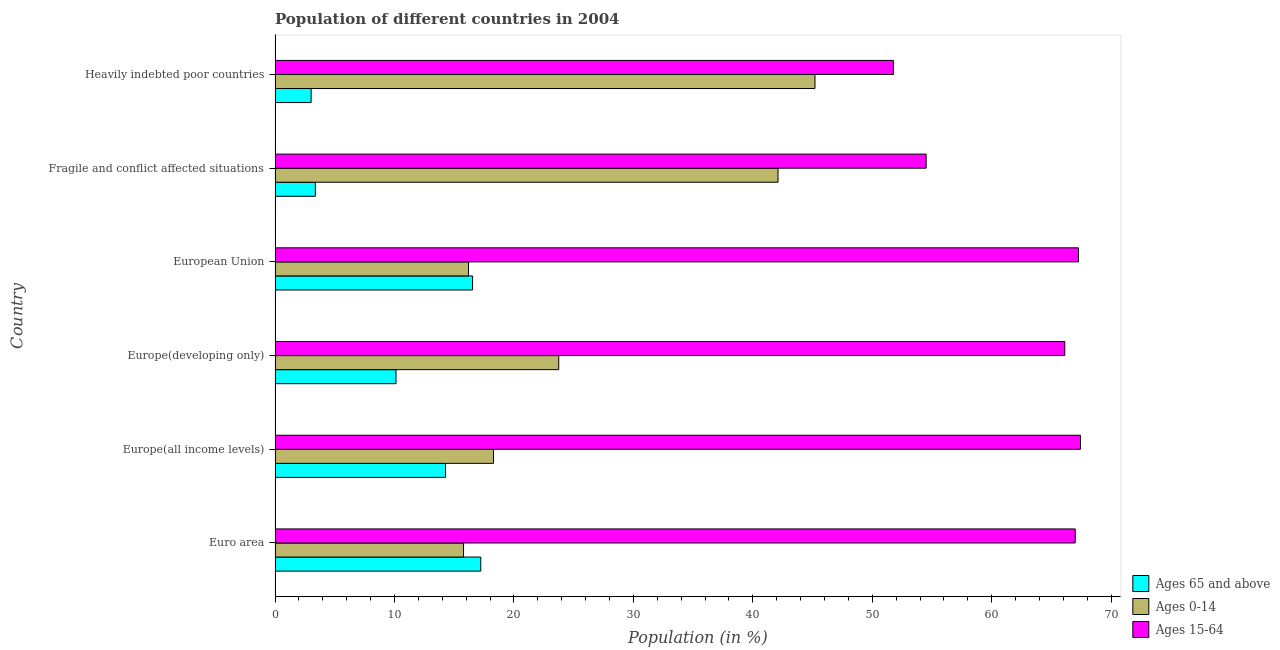How many different coloured bars are there?
Provide a succinct answer. 3. How many groups of bars are there?
Give a very brief answer. 6. Are the number of bars per tick equal to the number of legend labels?
Offer a terse response. Yes. Are the number of bars on each tick of the Y-axis equal?
Offer a very short reply. Yes. How many bars are there on the 2nd tick from the bottom?
Ensure brevity in your answer.  3. What is the label of the 4th group of bars from the top?
Offer a terse response. Europe(developing only). In how many cases, is the number of bars for a given country not equal to the number of legend labels?
Provide a short and direct response. 0. What is the percentage of population within the age-group of 65 and above in Fragile and conflict affected situations?
Your answer should be compact. 3.37. Across all countries, what is the maximum percentage of population within the age-group 0-14?
Your answer should be compact. 45.21. Across all countries, what is the minimum percentage of population within the age-group 15-64?
Offer a very short reply. 51.77. In which country was the percentage of population within the age-group 15-64 minimum?
Your answer should be compact. Heavily indebted poor countries. What is the total percentage of population within the age-group 15-64 in the graph?
Ensure brevity in your answer.  374.12. What is the difference between the percentage of population within the age-group 15-64 in Euro area and that in Europe(all income levels)?
Your answer should be compact. -0.44. What is the difference between the percentage of population within the age-group 0-14 in Heavily indebted poor countries and the percentage of population within the age-group 15-64 in Fragile and conflict affected situations?
Your answer should be compact. -9.31. What is the average percentage of population within the age-group 0-14 per country?
Offer a terse response. 26.89. What is the difference between the percentage of population within the age-group 0-14 and percentage of population within the age-group 15-64 in Euro area?
Your response must be concise. -51.22. In how many countries, is the percentage of population within the age-group 15-64 greater than 18 %?
Provide a short and direct response. 6. What is the ratio of the percentage of population within the age-group 0-14 in Euro area to that in Heavily indebted poor countries?
Ensure brevity in your answer.  0.35. Is the percentage of population within the age-group 15-64 in Europe(developing only) less than that in Fragile and conflict affected situations?
Your answer should be compact. No. Is the difference between the percentage of population within the age-group of 65 and above in Europe(developing only) and Fragile and conflict affected situations greater than the difference between the percentage of population within the age-group 0-14 in Europe(developing only) and Fragile and conflict affected situations?
Provide a short and direct response. Yes. What is the difference between the highest and the second highest percentage of population within the age-group 15-64?
Keep it short and to the point. 0.17. Is the sum of the percentage of population within the age-group 0-14 in European Union and Fragile and conflict affected situations greater than the maximum percentage of population within the age-group 15-64 across all countries?
Provide a succinct answer. No. What does the 2nd bar from the top in European Union represents?
Provide a succinct answer. Ages 0-14. What does the 3rd bar from the bottom in Heavily indebted poor countries represents?
Ensure brevity in your answer.  Ages 15-64. Is it the case that in every country, the sum of the percentage of population within the age-group of 65 and above and percentage of population within the age-group 0-14 is greater than the percentage of population within the age-group 15-64?
Provide a short and direct response. No. How many bars are there?
Keep it short and to the point. 18. What is the difference between two consecutive major ticks on the X-axis?
Offer a very short reply. 10. Are the values on the major ticks of X-axis written in scientific E-notation?
Offer a very short reply. No. Does the graph contain grids?
Ensure brevity in your answer.  No. Where does the legend appear in the graph?
Offer a very short reply. Bottom right. What is the title of the graph?
Keep it short and to the point. Population of different countries in 2004. What is the label or title of the X-axis?
Offer a very short reply. Population (in %). What is the Population (in %) in Ages 65 and above in Euro area?
Keep it short and to the point. 17.22. What is the Population (in %) in Ages 0-14 in Euro area?
Provide a short and direct response. 15.78. What is the Population (in %) of Ages 15-64 in Euro area?
Offer a very short reply. 67. What is the Population (in %) of Ages 65 and above in Europe(all income levels)?
Your response must be concise. 14.27. What is the Population (in %) of Ages 0-14 in Europe(all income levels)?
Your answer should be compact. 18.29. What is the Population (in %) of Ages 15-64 in Europe(all income levels)?
Your answer should be compact. 67.44. What is the Population (in %) in Ages 65 and above in Europe(developing only)?
Give a very brief answer. 10.13. What is the Population (in %) of Ages 0-14 in Europe(developing only)?
Ensure brevity in your answer.  23.75. What is the Population (in %) of Ages 15-64 in Europe(developing only)?
Your response must be concise. 66.12. What is the Population (in %) of Ages 65 and above in European Union?
Offer a terse response. 16.53. What is the Population (in %) of Ages 0-14 in European Union?
Offer a terse response. 16.2. What is the Population (in %) in Ages 15-64 in European Union?
Provide a short and direct response. 67.27. What is the Population (in %) in Ages 65 and above in Fragile and conflict affected situations?
Ensure brevity in your answer.  3.37. What is the Population (in %) in Ages 0-14 in Fragile and conflict affected situations?
Your answer should be very brief. 42.11. What is the Population (in %) of Ages 15-64 in Fragile and conflict affected situations?
Make the answer very short. 54.51. What is the Population (in %) in Ages 65 and above in Heavily indebted poor countries?
Provide a short and direct response. 3.02. What is the Population (in %) in Ages 0-14 in Heavily indebted poor countries?
Your answer should be compact. 45.21. What is the Population (in %) of Ages 15-64 in Heavily indebted poor countries?
Offer a terse response. 51.77. Across all countries, what is the maximum Population (in %) of Ages 65 and above?
Keep it short and to the point. 17.22. Across all countries, what is the maximum Population (in %) in Ages 0-14?
Offer a very short reply. 45.21. Across all countries, what is the maximum Population (in %) in Ages 15-64?
Make the answer very short. 67.44. Across all countries, what is the minimum Population (in %) in Ages 65 and above?
Your answer should be compact. 3.02. Across all countries, what is the minimum Population (in %) in Ages 0-14?
Offer a very short reply. 15.78. Across all countries, what is the minimum Population (in %) in Ages 15-64?
Offer a very short reply. 51.77. What is the total Population (in %) in Ages 65 and above in the graph?
Your answer should be very brief. 64.54. What is the total Population (in %) of Ages 0-14 in the graph?
Your answer should be compact. 161.34. What is the total Population (in %) in Ages 15-64 in the graph?
Provide a succinct answer. 374.12. What is the difference between the Population (in %) of Ages 65 and above in Euro area and that in Europe(all income levels)?
Your answer should be very brief. 2.95. What is the difference between the Population (in %) of Ages 0-14 in Euro area and that in Europe(all income levels)?
Offer a very short reply. -2.51. What is the difference between the Population (in %) of Ages 15-64 in Euro area and that in Europe(all income levels)?
Keep it short and to the point. -0.44. What is the difference between the Population (in %) in Ages 65 and above in Euro area and that in Europe(developing only)?
Ensure brevity in your answer.  7.1. What is the difference between the Population (in %) of Ages 0-14 in Euro area and that in Europe(developing only)?
Offer a very short reply. -7.97. What is the difference between the Population (in %) in Ages 15-64 in Euro area and that in Europe(developing only)?
Offer a very short reply. 0.88. What is the difference between the Population (in %) in Ages 65 and above in Euro area and that in European Union?
Make the answer very short. 0.69. What is the difference between the Population (in %) of Ages 0-14 in Euro area and that in European Union?
Give a very brief answer. -0.42. What is the difference between the Population (in %) in Ages 15-64 in Euro area and that in European Union?
Offer a very short reply. -0.27. What is the difference between the Population (in %) in Ages 65 and above in Euro area and that in Fragile and conflict affected situations?
Make the answer very short. 13.85. What is the difference between the Population (in %) in Ages 0-14 in Euro area and that in Fragile and conflict affected situations?
Keep it short and to the point. -26.33. What is the difference between the Population (in %) in Ages 15-64 in Euro area and that in Fragile and conflict affected situations?
Make the answer very short. 12.48. What is the difference between the Population (in %) of Ages 65 and above in Euro area and that in Heavily indebted poor countries?
Your answer should be very brief. 14.2. What is the difference between the Population (in %) of Ages 0-14 in Euro area and that in Heavily indebted poor countries?
Ensure brevity in your answer.  -29.43. What is the difference between the Population (in %) of Ages 15-64 in Euro area and that in Heavily indebted poor countries?
Offer a terse response. 15.22. What is the difference between the Population (in %) of Ages 65 and above in Europe(all income levels) and that in Europe(developing only)?
Give a very brief answer. 4.14. What is the difference between the Population (in %) of Ages 0-14 in Europe(all income levels) and that in Europe(developing only)?
Ensure brevity in your answer.  -5.46. What is the difference between the Population (in %) of Ages 15-64 in Europe(all income levels) and that in Europe(developing only)?
Your answer should be very brief. 1.32. What is the difference between the Population (in %) in Ages 65 and above in Europe(all income levels) and that in European Union?
Ensure brevity in your answer.  -2.26. What is the difference between the Population (in %) of Ages 0-14 in Europe(all income levels) and that in European Union?
Offer a terse response. 2.09. What is the difference between the Population (in %) in Ages 15-64 in Europe(all income levels) and that in European Union?
Give a very brief answer. 0.17. What is the difference between the Population (in %) of Ages 65 and above in Europe(all income levels) and that in Fragile and conflict affected situations?
Ensure brevity in your answer.  10.9. What is the difference between the Population (in %) of Ages 0-14 in Europe(all income levels) and that in Fragile and conflict affected situations?
Your answer should be compact. -23.82. What is the difference between the Population (in %) in Ages 15-64 in Europe(all income levels) and that in Fragile and conflict affected situations?
Ensure brevity in your answer.  12.93. What is the difference between the Population (in %) of Ages 65 and above in Europe(all income levels) and that in Heavily indebted poor countries?
Keep it short and to the point. 11.25. What is the difference between the Population (in %) in Ages 0-14 in Europe(all income levels) and that in Heavily indebted poor countries?
Offer a very short reply. -26.92. What is the difference between the Population (in %) in Ages 15-64 in Europe(all income levels) and that in Heavily indebted poor countries?
Your answer should be very brief. 15.67. What is the difference between the Population (in %) of Ages 65 and above in Europe(developing only) and that in European Union?
Give a very brief answer. -6.41. What is the difference between the Population (in %) of Ages 0-14 in Europe(developing only) and that in European Union?
Offer a very short reply. 7.56. What is the difference between the Population (in %) of Ages 15-64 in Europe(developing only) and that in European Union?
Your answer should be very brief. -1.15. What is the difference between the Population (in %) in Ages 65 and above in Europe(developing only) and that in Fragile and conflict affected situations?
Make the answer very short. 6.75. What is the difference between the Population (in %) in Ages 0-14 in Europe(developing only) and that in Fragile and conflict affected situations?
Offer a terse response. -18.36. What is the difference between the Population (in %) of Ages 15-64 in Europe(developing only) and that in Fragile and conflict affected situations?
Give a very brief answer. 11.61. What is the difference between the Population (in %) of Ages 65 and above in Europe(developing only) and that in Heavily indebted poor countries?
Make the answer very short. 7.11. What is the difference between the Population (in %) in Ages 0-14 in Europe(developing only) and that in Heavily indebted poor countries?
Provide a succinct answer. -21.45. What is the difference between the Population (in %) in Ages 15-64 in Europe(developing only) and that in Heavily indebted poor countries?
Ensure brevity in your answer.  14.35. What is the difference between the Population (in %) in Ages 65 and above in European Union and that in Fragile and conflict affected situations?
Make the answer very short. 13.16. What is the difference between the Population (in %) in Ages 0-14 in European Union and that in Fragile and conflict affected situations?
Your answer should be very brief. -25.92. What is the difference between the Population (in %) in Ages 15-64 in European Union and that in Fragile and conflict affected situations?
Your answer should be compact. 12.76. What is the difference between the Population (in %) of Ages 65 and above in European Union and that in Heavily indebted poor countries?
Give a very brief answer. 13.51. What is the difference between the Population (in %) of Ages 0-14 in European Union and that in Heavily indebted poor countries?
Your answer should be compact. -29.01. What is the difference between the Population (in %) of Ages 15-64 in European Union and that in Heavily indebted poor countries?
Ensure brevity in your answer.  15.5. What is the difference between the Population (in %) in Ages 65 and above in Fragile and conflict affected situations and that in Heavily indebted poor countries?
Offer a terse response. 0.35. What is the difference between the Population (in %) in Ages 0-14 in Fragile and conflict affected situations and that in Heavily indebted poor countries?
Your answer should be compact. -3.09. What is the difference between the Population (in %) in Ages 15-64 in Fragile and conflict affected situations and that in Heavily indebted poor countries?
Offer a very short reply. 2.74. What is the difference between the Population (in %) in Ages 65 and above in Euro area and the Population (in %) in Ages 0-14 in Europe(all income levels)?
Provide a short and direct response. -1.07. What is the difference between the Population (in %) of Ages 65 and above in Euro area and the Population (in %) of Ages 15-64 in Europe(all income levels)?
Your answer should be very brief. -50.22. What is the difference between the Population (in %) of Ages 0-14 in Euro area and the Population (in %) of Ages 15-64 in Europe(all income levels)?
Provide a short and direct response. -51.66. What is the difference between the Population (in %) of Ages 65 and above in Euro area and the Population (in %) of Ages 0-14 in Europe(developing only)?
Offer a terse response. -6.53. What is the difference between the Population (in %) of Ages 65 and above in Euro area and the Population (in %) of Ages 15-64 in Europe(developing only)?
Your answer should be very brief. -48.9. What is the difference between the Population (in %) in Ages 0-14 in Euro area and the Population (in %) in Ages 15-64 in Europe(developing only)?
Offer a terse response. -50.34. What is the difference between the Population (in %) in Ages 65 and above in Euro area and the Population (in %) in Ages 0-14 in European Union?
Provide a short and direct response. 1.03. What is the difference between the Population (in %) in Ages 65 and above in Euro area and the Population (in %) in Ages 15-64 in European Union?
Keep it short and to the point. -50.05. What is the difference between the Population (in %) in Ages 0-14 in Euro area and the Population (in %) in Ages 15-64 in European Union?
Provide a short and direct response. -51.49. What is the difference between the Population (in %) in Ages 65 and above in Euro area and the Population (in %) in Ages 0-14 in Fragile and conflict affected situations?
Offer a terse response. -24.89. What is the difference between the Population (in %) of Ages 65 and above in Euro area and the Population (in %) of Ages 15-64 in Fragile and conflict affected situations?
Give a very brief answer. -37.29. What is the difference between the Population (in %) in Ages 0-14 in Euro area and the Population (in %) in Ages 15-64 in Fragile and conflict affected situations?
Offer a very short reply. -38.73. What is the difference between the Population (in %) in Ages 65 and above in Euro area and the Population (in %) in Ages 0-14 in Heavily indebted poor countries?
Keep it short and to the point. -27.98. What is the difference between the Population (in %) in Ages 65 and above in Euro area and the Population (in %) in Ages 15-64 in Heavily indebted poor countries?
Make the answer very short. -34.55. What is the difference between the Population (in %) in Ages 0-14 in Euro area and the Population (in %) in Ages 15-64 in Heavily indebted poor countries?
Keep it short and to the point. -35.99. What is the difference between the Population (in %) of Ages 65 and above in Europe(all income levels) and the Population (in %) of Ages 0-14 in Europe(developing only)?
Provide a short and direct response. -9.48. What is the difference between the Population (in %) of Ages 65 and above in Europe(all income levels) and the Population (in %) of Ages 15-64 in Europe(developing only)?
Make the answer very short. -51.85. What is the difference between the Population (in %) in Ages 0-14 in Europe(all income levels) and the Population (in %) in Ages 15-64 in Europe(developing only)?
Offer a terse response. -47.83. What is the difference between the Population (in %) in Ages 65 and above in Europe(all income levels) and the Population (in %) in Ages 0-14 in European Union?
Provide a short and direct response. -1.93. What is the difference between the Population (in %) in Ages 65 and above in Europe(all income levels) and the Population (in %) in Ages 15-64 in European Union?
Offer a very short reply. -53. What is the difference between the Population (in %) of Ages 0-14 in Europe(all income levels) and the Population (in %) of Ages 15-64 in European Union?
Provide a succinct answer. -48.98. What is the difference between the Population (in %) in Ages 65 and above in Europe(all income levels) and the Population (in %) in Ages 0-14 in Fragile and conflict affected situations?
Offer a terse response. -27.84. What is the difference between the Population (in %) of Ages 65 and above in Europe(all income levels) and the Population (in %) of Ages 15-64 in Fragile and conflict affected situations?
Keep it short and to the point. -40.24. What is the difference between the Population (in %) in Ages 0-14 in Europe(all income levels) and the Population (in %) in Ages 15-64 in Fragile and conflict affected situations?
Your answer should be very brief. -36.23. What is the difference between the Population (in %) in Ages 65 and above in Europe(all income levels) and the Population (in %) in Ages 0-14 in Heavily indebted poor countries?
Your answer should be compact. -30.94. What is the difference between the Population (in %) in Ages 65 and above in Europe(all income levels) and the Population (in %) in Ages 15-64 in Heavily indebted poor countries?
Offer a terse response. -37.5. What is the difference between the Population (in %) in Ages 0-14 in Europe(all income levels) and the Population (in %) in Ages 15-64 in Heavily indebted poor countries?
Offer a terse response. -33.48. What is the difference between the Population (in %) in Ages 65 and above in Europe(developing only) and the Population (in %) in Ages 0-14 in European Union?
Give a very brief answer. -6.07. What is the difference between the Population (in %) in Ages 65 and above in Europe(developing only) and the Population (in %) in Ages 15-64 in European Union?
Provide a short and direct response. -57.14. What is the difference between the Population (in %) in Ages 0-14 in Europe(developing only) and the Population (in %) in Ages 15-64 in European Union?
Keep it short and to the point. -43.52. What is the difference between the Population (in %) of Ages 65 and above in Europe(developing only) and the Population (in %) of Ages 0-14 in Fragile and conflict affected situations?
Offer a terse response. -31.99. What is the difference between the Population (in %) of Ages 65 and above in Europe(developing only) and the Population (in %) of Ages 15-64 in Fragile and conflict affected situations?
Offer a terse response. -44.39. What is the difference between the Population (in %) of Ages 0-14 in Europe(developing only) and the Population (in %) of Ages 15-64 in Fragile and conflict affected situations?
Keep it short and to the point. -30.76. What is the difference between the Population (in %) in Ages 65 and above in Europe(developing only) and the Population (in %) in Ages 0-14 in Heavily indebted poor countries?
Provide a succinct answer. -35.08. What is the difference between the Population (in %) in Ages 65 and above in Europe(developing only) and the Population (in %) in Ages 15-64 in Heavily indebted poor countries?
Keep it short and to the point. -41.65. What is the difference between the Population (in %) of Ages 0-14 in Europe(developing only) and the Population (in %) of Ages 15-64 in Heavily indebted poor countries?
Provide a succinct answer. -28.02. What is the difference between the Population (in %) in Ages 65 and above in European Union and the Population (in %) in Ages 0-14 in Fragile and conflict affected situations?
Make the answer very short. -25.58. What is the difference between the Population (in %) of Ages 65 and above in European Union and the Population (in %) of Ages 15-64 in Fragile and conflict affected situations?
Provide a succinct answer. -37.98. What is the difference between the Population (in %) in Ages 0-14 in European Union and the Population (in %) in Ages 15-64 in Fragile and conflict affected situations?
Make the answer very short. -38.32. What is the difference between the Population (in %) of Ages 65 and above in European Union and the Population (in %) of Ages 0-14 in Heavily indebted poor countries?
Offer a very short reply. -28.67. What is the difference between the Population (in %) in Ages 65 and above in European Union and the Population (in %) in Ages 15-64 in Heavily indebted poor countries?
Provide a short and direct response. -35.24. What is the difference between the Population (in %) of Ages 0-14 in European Union and the Population (in %) of Ages 15-64 in Heavily indebted poor countries?
Provide a succinct answer. -35.58. What is the difference between the Population (in %) in Ages 65 and above in Fragile and conflict affected situations and the Population (in %) in Ages 0-14 in Heavily indebted poor countries?
Offer a terse response. -41.83. What is the difference between the Population (in %) of Ages 65 and above in Fragile and conflict affected situations and the Population (in %) of Ages 15-64 in Heavily indebted poor countries?
Offer a terse response. -48.4. What is the difference between the Population (in %) of Ages 0-14 in Fragile and conflict affected situations and the Population (in %) of Ages 15-64 in Heavily indebted poor countries?
Offer a very short reply. -9.66. What is the average Population (in %) of Ages 65 and above per country?
Offer a terse response. 10.76. What is the average Population (in %) of Ages 0-14 per country?
Provide a short and direct response. 26.89. What is the average Population (in %) of Ages 15-64 per country?
Keep it short and to the point. 62.35. What is the difference between the Population (in %) of Ages 65 and above and Population (in %) of Ages 0-14 in Euro area?
Offer a terse response. 1.44. What is the difference between the Population (in %) in Ages 65 and above and Population (in %) in Ages 15-64 in Euro area?
Ensure brevity in your answer.  -49.78. What is the difference between the Population (in %) in Ages 0-14 and Population (in %) in Ages 15-64 in Euro area?
Give a very brief answer. -51.22. What is the difference between the Population (in %) of Ages 65 and above and Population (in %) of Ages 0-14 in Europe(all income levels)?
Keep it short and to the point. -4.02. What is the difference between the Population (in %) in Ages 65 and above and Population (in %) in Ages 15-64 in Europe(all income levels)?
Give a very brief answer. -53.17. What is the difference between the Population (in %) in Ages 0-14 and Population (in %) in Ages 15-64 in Europe(all income levels)?
Make the answer very short. -49.15. What is the difference between the Population (in %) in Ages 65 and above and Population (in %) in Ages 0-14 in Europe(developing only)?
Your answer should be compact. -13.62. What is the difference between the Population (in %) in Ages 65 and above and Population (in %) in Ages 15-64 in Europe(developing only)?
Offer a terse response. -55.99. What is the difference between the Population (in %) of Ages 0-14 and Population (in %) of Ages 15-64 in Europe(developing only)?
Provide a short and direct response. -42.37. What is the difference between the Population (in %) in Ages 65 and above and Population (in %) in Ages 0-14 in European Union?
Offer a very short reply. 0.34. What is the difference between the Population (in %) of Ages 65 and above and Population (in %) of Ages 15-64 in European Union?
Ensure brevity in your answer.  -50.74. What is the difference between the Population (in %) of Ages 0-14 and Population (in %) of Ages 15-64 in European Union?
Your response must be concise. -51.07. What is the difference between the Population (in %) of Ages 65 and above and Population (in %) of Ages 0-14 in Fragile and conflict affected situations?
Provide a short and direct response. -38.74. What is the difference between the Population (in %) in Ages 65 and above and Population (in %) in Ages 15-64 in Fragile and conflict affected situations?
Offer a terse response. -51.14. What is the difference between the Population (in %) of Ages 0-14 and Population (in %) of Ages 15-64 in Fragile and conflict affected situations?
Provide a short and direct response. -12.4. What is the difference between the Population (in %) of Ages 65 and above and Population (in %) of Ages 0-14 in Heavily indebted poor countries?
Keep it short and to the point. -42.19. What is the difference between the Population (in %) in Ages 65 and above and Population (in %) in Ages 15-64 in Heavily indebted poor countries?
Ensure brevity in your answer.  -48.75. What is the difference between the Population (in %) in Ages 0-14 and Population (in %) in Ages 15-64 in Heavily indebted poor countries?
Your answer should be compact. -6.57. What is the ratio of the Population (in %) in Ages 65 and above in Euro area to that in Europe(all income levels)?
Your response must be concise. 1.21. What is the ratio of the Population (in %) in Ages 0-14 in Euro area to that in Europe(all income levels)?
Ensure brevity in your answer.  0.86. What is the ratio of the Population (in %) in Ages 15-64 in Euro area to that in Europe(all income levels)?
Offer a very short reply. 0.99. What is the ratio of the Population (in %) in Ages 65 and above in Euro area to that in Europe(developing only)?
Provide a succinct answer. 1.7. What is the ratio of the Population (in %) of Ages 0-14 in Euro area to that in Europe(developing only)?
Your response must be concise. 0.66. What is the ratio of the Population (in %) of Ages 15-64 in Euro area to that in Europe(developing only)?
Provide a short and direct response. 1.01. What is the ratio of the Population (in %) of Ages 65 and above in Euro area to that in European Union?
Offer a terse response. 1.04. What is the ratio of the Population (in %) in Ages 0-14 in Euro area to that in European Union?
Give a very brief answer. 0.97. What is the ratio of the Population (in %) in Ages 15-64 in Euro area to that in European Union?
Provide a short and direct response. 1. What is the ratio of the Population (in %) of Ages 65 and above in Euro area to that in Fragile and conflict affected situations?
Keep it short and to the point. 5.11. What is the ratio of the Population (in %) of Ages 0-14 in Euro area to that in Fragile and conflict affected situations?
Offer a very short reply. 0.37. What is the ratio of the Population (in %) of Ages 15-64 in Euro area to that in Fragile and conflict affected situations?
Provide a short and direct response. 1.23. What is the ratio of the Population (in %) in Ages 65 and above in Euro area to that in Heavily indebted poor countries?
Your answer should be compact. 5.7. What is the ratio of the Population (in %) of Ages 0-14 in Euro area to that in Heavily indebted poor countries?
Offer a very short reply. 0.35. What is the ratio of the Population (in %) of Ages 15-64 in Euro area to that in Heavily indebted poor countries?
Keep it short and to the point. 1.29. What is the ratio of the Population (in %) in Ages 65 and above in Europe(all income levels) to that in Europe(developing only)?
Provide a short and direct response. 1.41. What is the ratio of the Population (in %) in Ages 0-14 in Europe(all income levels) to that in Europe(developing only)?
Offer a terse response. 0.77. What is the ratio of the Population (in %) in Ages 65 and above in Europe(all income levels) to that in European Union?
Keep it short and to the point. 0.86. What is the ratio of the Population (in %) in Ages 0-14 in Europe(all income levels) to that in European Union?
Offer a terse response. 1.13. What is the ratio of the Population (in %) of Ages 15-64 in Europe(all income levels) to that in European Union?
Your answer should be very brief. 1. What is the ratio of the Population (in %) in Ages 65 and above in Europe(all income levels) to that in Fragile and conflict affected situations?
Offer a terse response. 4.23. What is the ratio of the Population (in %) of Ages 0-14 in Europe(all income levels) to that in Fragile and conflict affected situations?
Make the answer very short. 0.43. What is the ratio of the Population (in %) in Ages 15-64 in Europe(all income levels) to that in Fragile and conflict affected situations?
Give a very brief answer. 1.24. What is the ratio of the Population (in %) in Ages 65 and above in Europe(all income levels) to that in Heavily indebted poor countries?
Provide a succinct answer. 4.73. What is the ratio of the Population (in %) of Ages 0-14 in Europe(all income levels) to that in Heavily indebted poor countries?
Offer a terse response. 0.4. What is the ratio of the Population (in %) of Ages 15-64 in Europe(all income levels) to that in Heavily indebted poor countries?
Keep it short and to the point. 1.3. What is the ratio of the Population (in %) of Ages 65 and above in Europe(developing only) to that in European Union?
Your response must be concise. 0.61. What is the ratio of the Population (in %) of Ages 0-14 in Europe(developing only) to that in European Union?
Your response must be concise. 1.47. What is the ratio of the Population (in %) of Ages 15-64 in Europe(developing only) to that in European Union?
Keep it short and to the point. 0.98. What is the ratio of the Population (in %) of Ages 65 and above in Europe(developing only) to that in Fragile and conflict affected situations?
Provide a short and direct response. 3. What is the ratio of the Population (in %) in Ages 0-14 in Europe(developing only) to that in Fragile and conflict affected situations?
Offer a very short reply. 0.56. What is the ratio of the Population (in %) of Ages 15-64 in Europe(developing only) to that in Fragile and conflict affected situations?
Provide a short and direct response. 1.21. What is the ratio of the Population (in %) in Ages 65 and above in Europe(developing only) to that in Heavily indebted poor countries?
Give a very brief answer. 3.35. What is the ratio of the Population (in %) in Ages 0-14 in Europe(developing only) to that in Heavily indebted poor countries?
Provide a short and direct response. 0.53. What is the ratio of the Population (in %) in Ages 15-64 in Europe(developing only) to that in Heavily indebted poor countries?
Your answer should be compact. 1.28. What is the ratio of the Population (in %) of Ages 65 and above in European Union to that in Fragile and conflict affected situations?
Offer a terse response. 4.9. What is the ratio of the Population (in %) in Ages 0-14 in European Union to that in Fragile and conflict affected situations?
Offer a very short reply. 0.38. What is the ratio of the Population (in %) of Ages 15-64 in European Union to that in Fragile and conflict affected situations?
Offer a very short reply. 1.23. What is the ratio of the Population (in %) of Ages 65 and above in European Union to that in Heavily indebted poor countries?
Offer a very short reply. 5.47. What is the ratio of the Population (in %) of Ages 0-14 in European Union to that in Heavily indebted poor countries?
Your answer should be very brief. 0.36. What is the ratio of the Population (in %) of Ages 15-64 in European Union to that in Heavily indebted poor countries?
Provide a succinct answer. 1.3. What is the ratio of the Population (in %) of Ages 65 and above in Fragile and conflict affected situations to that in Heavily indebted poor countries?
Ensure brevity in your answer.  1.12. What is the ratio of the Population (in %) of Ages 0-14 in Fragile and conflict affected situations to that in Heavily indebted poor countries?
Provide a succinct answer. 0.93. What is the ratio of the Population (in %) of Ages 15-64 in Fragile and conflict affected situations to that in Heavily indebted poor countries?
Provide a short and direct response. 1.05. What is the difference between the highest and the second highest Population (in %) of Ages 65 and above?
Provide a succinct answer. 0.69. What is the difference between the highest and the second highest Population (in %) of Ages 0-14?
Your answer should be very brief. 3.09. What is the difference between the highest and the second highest Population (in %) of Ages 15-64?
Offer a terse response. 0.17. What is the difference between the highest and the lowest Population (in %) in Ages 65 and above?
Offer a terse response. 14.2. What is the difference between the highest and the lowest Population (in %) in Ages 0-14?
Your answer should be very brief. 29.43. What is the difference between the highest and the lowest Population (in %) of Ages 15-64?
Offer a very short reply. 15.67. 